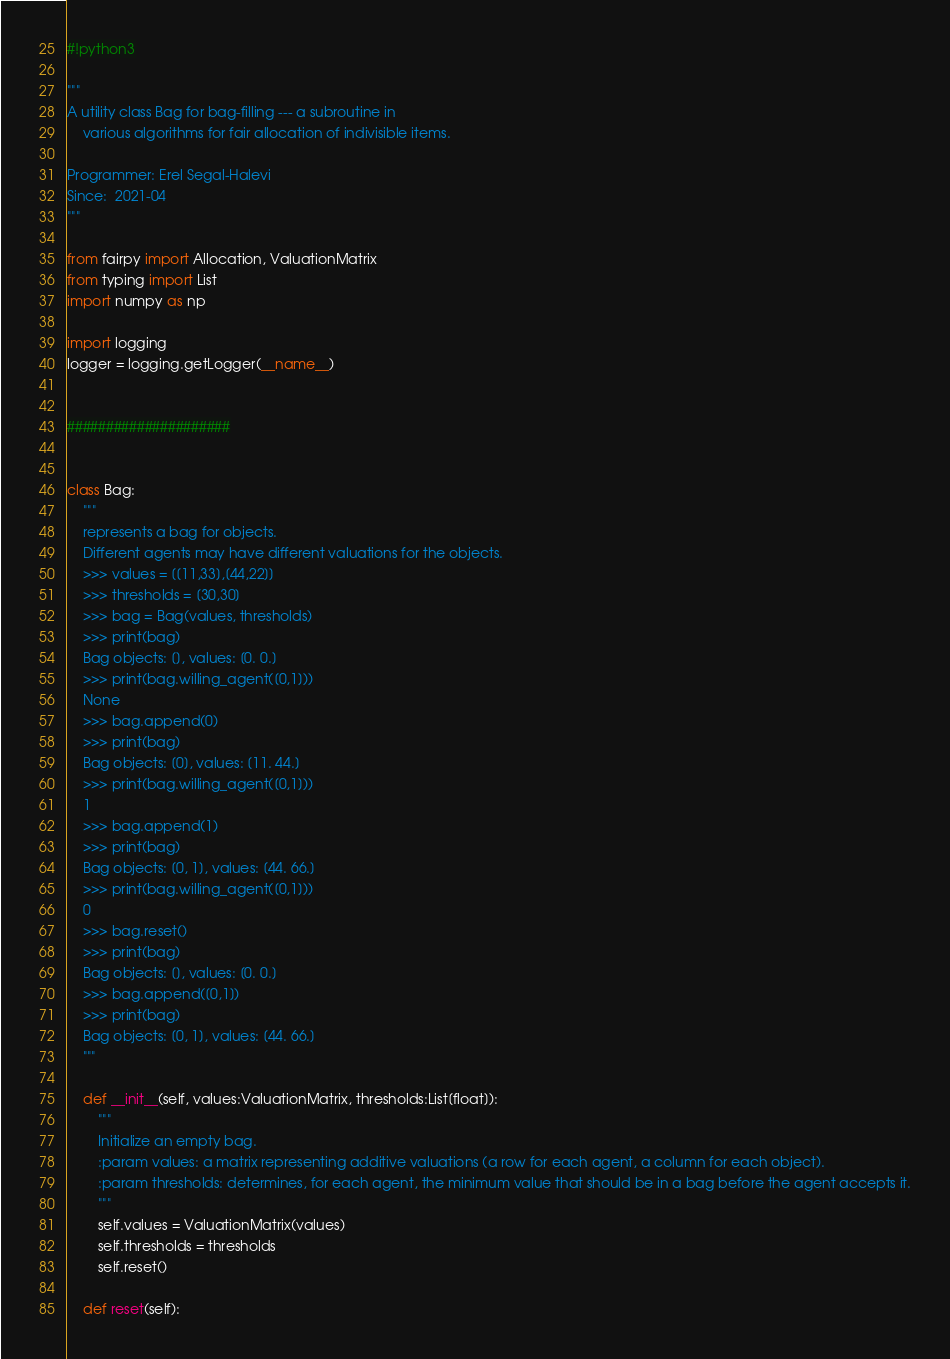<code> <loc_0><loc_0><loc_500><loc_500><_Python_>#!python3

"""
A utility class Bag for bag-filling --- a subroutine in 
    various algorithms for fair allocation of indivisible items.

Programmer: Erel Segal-Halevi
Since:  2021-04
"""

from fairpy import Allocation, ValuationMatrix
from typing import List
import numpy as np

import logging
logger = logging.getLogger(__name__)


#####################


class Bag:
	"""
	represents a bag for objects. 
	Different agents may have different valuations for the objects.
	>>> values = [[11,33],[44,22]]
	>>> thresholds = [30,30]
	>>> bag = Bag(values, thresholds)
	>>> print(bag)
	Bag objects: [], values: [0. 0.]
	>>> print(bag.willing_agent([0,1]))
	None
	>>> bag.append(0)
	>>> print(bag)
	Bag objects: [0], values: [11. 44.]
	>>> print(bag.willing_agent([0,1]))
	1
	>>> bag.append(1)
	>>> print(bag)
	Bag objects: [0, 1], values: [44. 66.]
	>>> print(bag.willing_agent([0,1]))
	0
	>>> bag.reset()
	>>> print(bag)
	Bag objects: [], values: [0. 0.]
	>>> bag.append([0,1])
	>>> print(bag)
	Bag objects: [0, 1], values: [44. 66.]
	"""

	def __init__(self, values:ValuationMatrix, thresholds:List[float]):
		"""
		Initialize an empty bag.
		:param values: a matrix representing additive valuations (a row for each agent, a column for each object).
		:param thresholds: determines, for each agent, the minimum value that should be in a bag before the agent accepts it.
		"""
		self.values = ValuationMatrix(values)
		self.thresholds = thresholds
		self.reset()

	def reset(self): </code> 